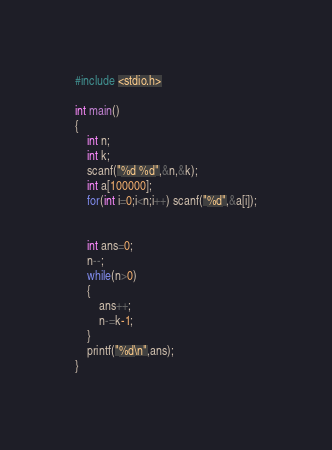<code> <loc_0><loc_0><loc_500><loc_500><_C++_>#include <stdio.h>

int main()
{
    int n;
    int k;
    scanf("%d %d",&n,&k);
    int a[100000];
    for(int i=0;i<n;i++) scanf("%d",&a[i]);


    int ans=0;
    n--;
    while(n>0)
    {
        ans++;
        n-=k-1;
    }
    printf("%d\n",ans);
}</code> 